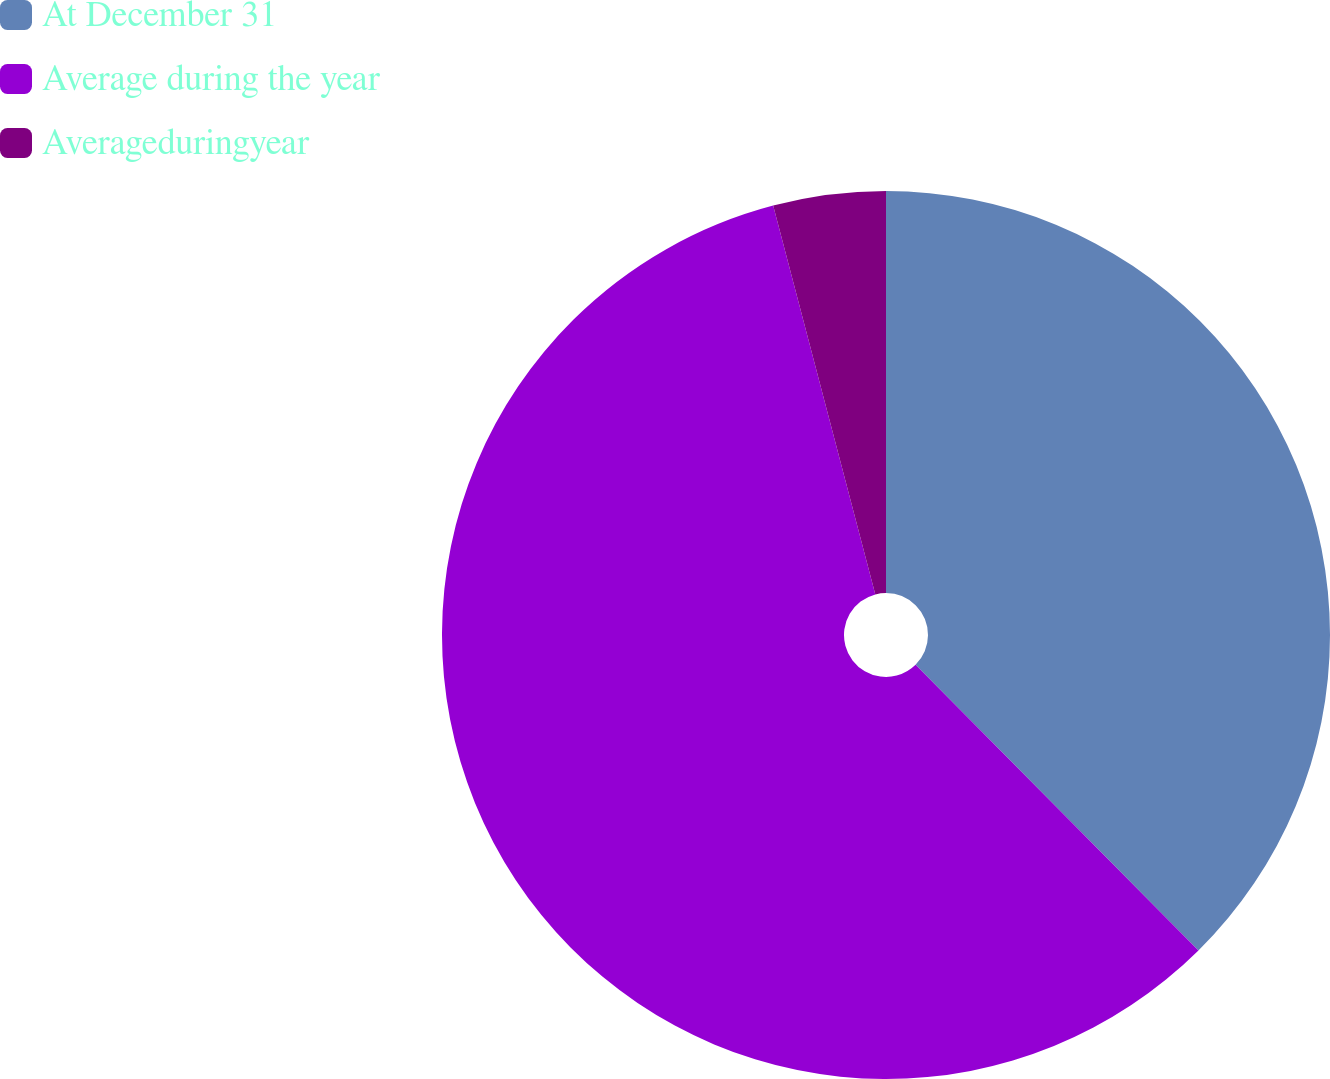Convert chart. <chart><loc_0><loc_0><loc_500><loc_500><pie_chart><fcel>At December 31<fcel>Average during the year<fcel>Averageduringyear<nl><fcel>37.58%<fcel>58.34%<fcel>4.09%<nl></chart> 